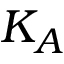Convert formula to latex. <formula><loc_0><loc_0><loc_500><loc_500>K _ { A }</formula> 